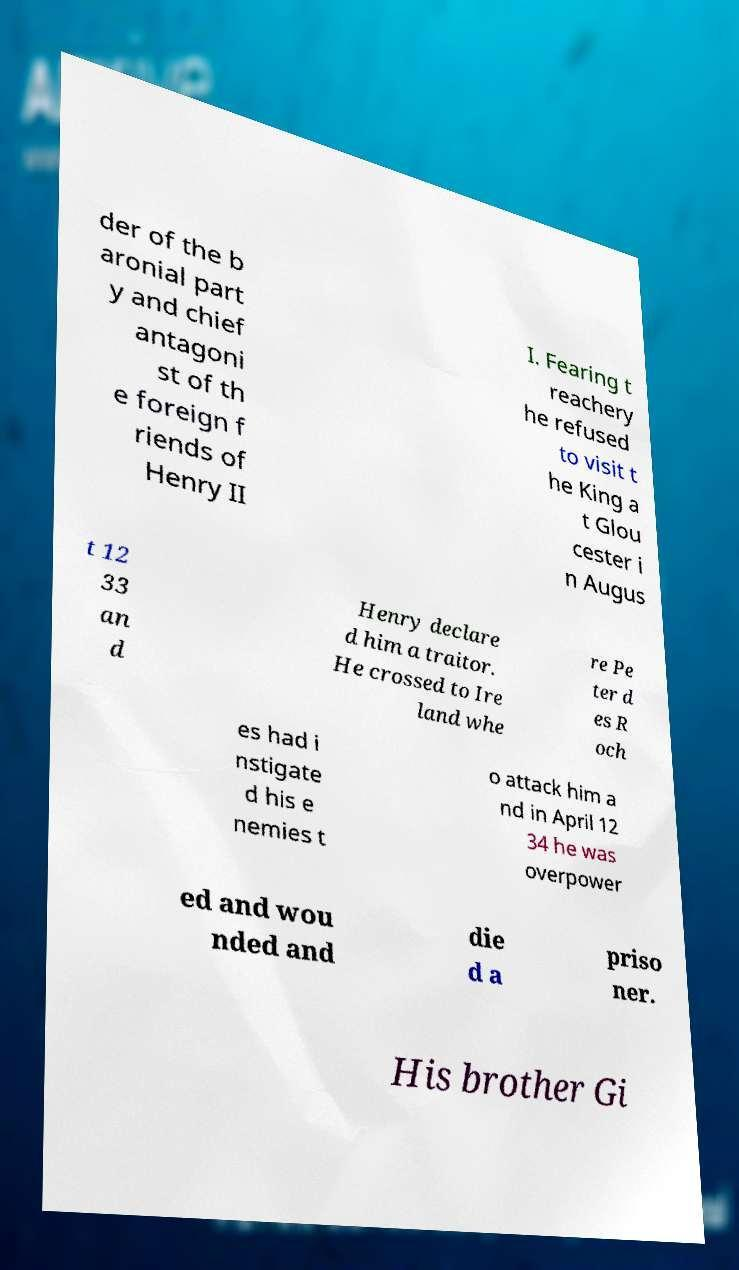There's text embedded in this image that I need extracted. Can you transcribe it verbatim? der of the b aronial part y and chief antagoni st of th e foreign f riends of Henry II I. Fearing t reachery he refused to visit t he King a t Glou cester i n Augus t 12 33 an d Henry declare d him a traitor. He crossed to Ire land whe re Pe ter d es R och es had i nstigate d his e nemies t o attack him a nd in April 12 34 he was overpower ed and wou nded and die d a priso ner. His brother Gi 